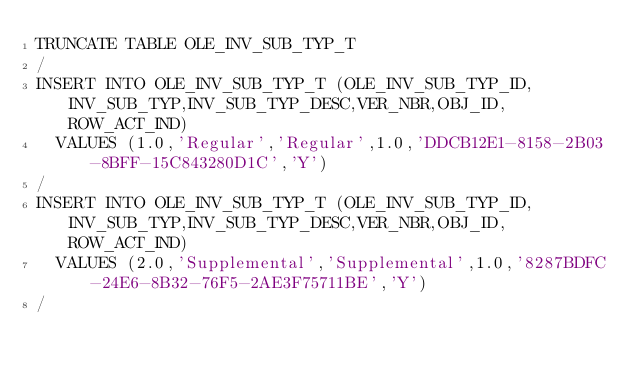Convert code to text. <code><loc_0><loc_0><loc_500><loc_500><_SQL_>TRUNCATE TABLE OLE_INV_SUB_TYP_T
/
INSERT INTO OLE_INV_SUB_TYP_T (OLE_INV_SUB_TYP_ID,INV_SUB_TYP,INV_SUB_TYP_DESC,VER_NBR,OBJ_ID,ROW_ACT_IND)
  VALUES (1.0,'Regular','Regular',1.0,'DDCB12E1-8158-2B03-8BFF-15C843280D1C','Y')
/
INSERT INTO OLE_INV_SUB_TYP_T (OLE_INV_SUB_TYP_ID,INV_SUB_TYP,INV_SUB_TYP_DESC,VER_NBR,OBJ_ID,ROW_ACT_IND)
  VALUES (2.0,'Supplemental','Supplemental',1.0,'8287BDFC-24E6-8B32-76F5-2AE3F75711BE','Y')
/
</code> 